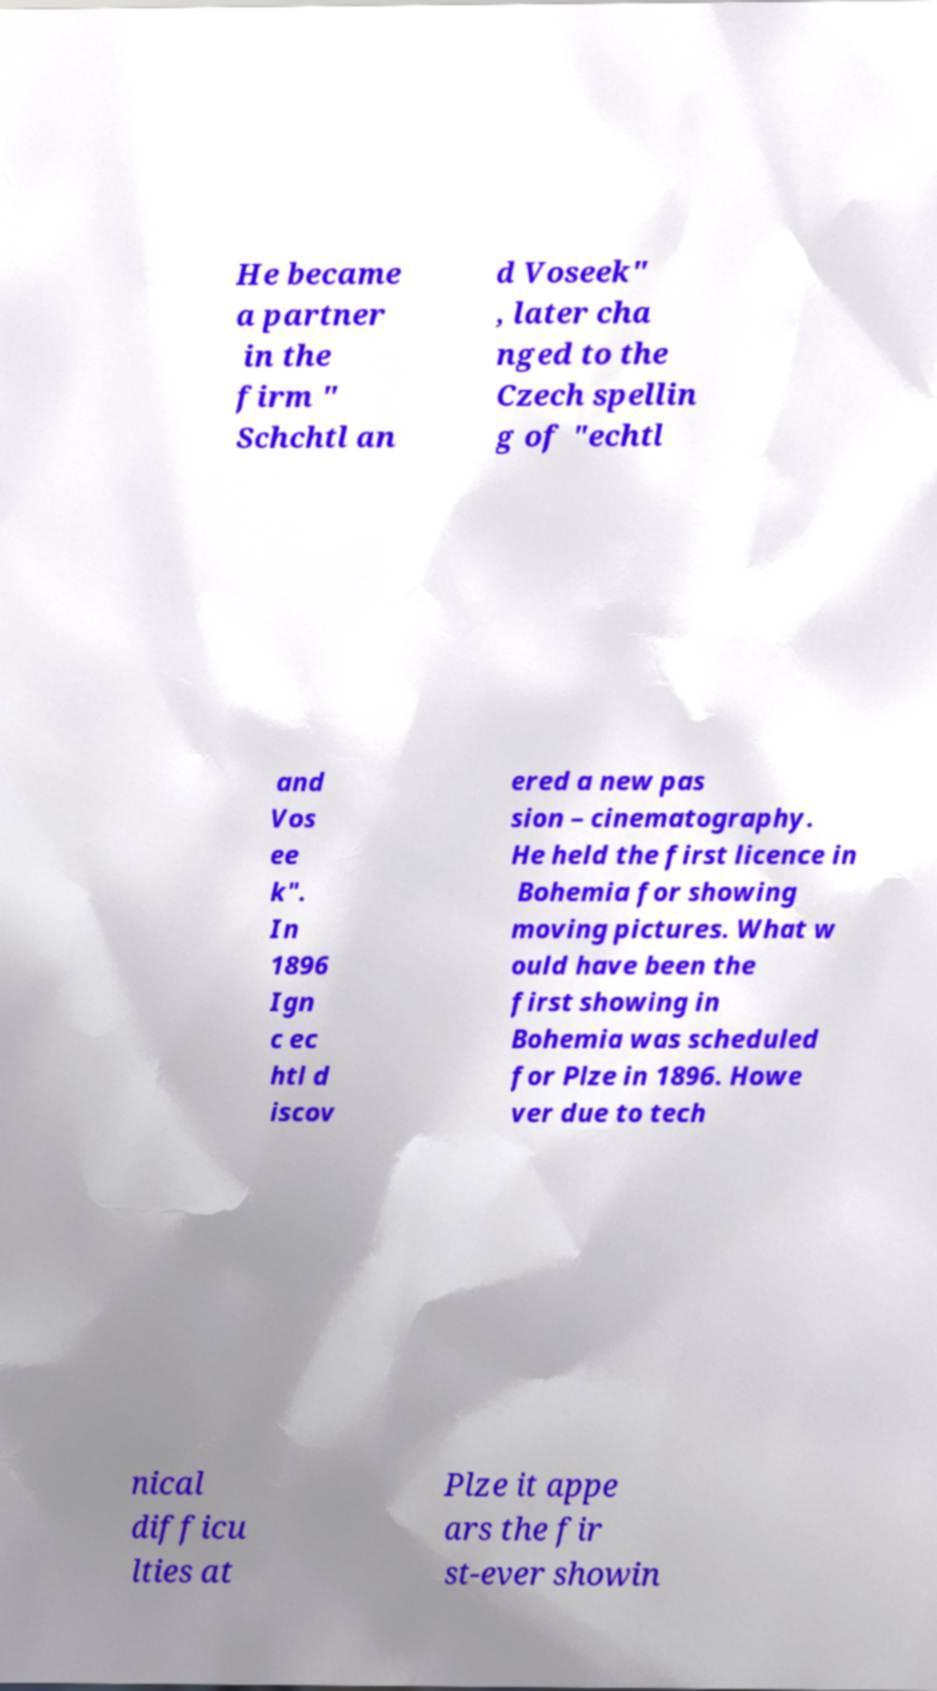Please read and relay the text visible in this image. What does it say? He became a partner in the firm " Schchtl an d Voseek" , later cha nged to the Czech spellin g of "echtl and Vos ee k". In 1896 Ign c ec htl d iscov ered a new pas sion – cinematography. He held the first licence in Bohemia for showing moving pictures. What w ould have been the first showing in Bohemia was scheduled for Plze in 1896. Howe ver due to tech nical difficu lties at Plze it appe ars the fir st-ever showin 